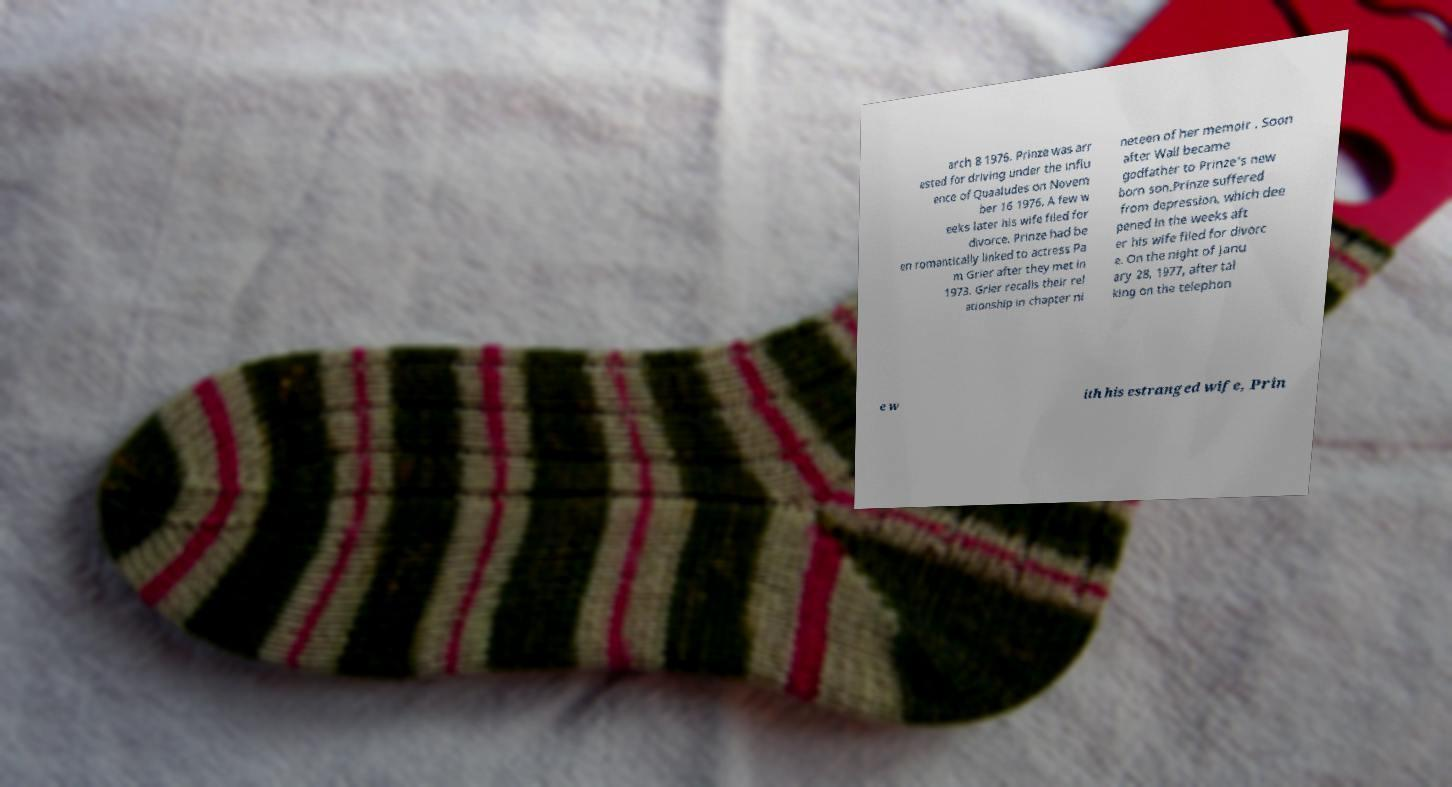Can you read and provide the text displayed in the image?This photo seems to have some interesting text. Can you extract and type it out for me? arch 8 1976. Prinze was arr ested for driving under the influ ence of Quaaludes on Novem ber 16 1976. A few w eeks later his wife filed for divorce. Prinze had be en romantically linked to actress Pa m Grier after they met in 1973. Grier recalls their rel ationship in chapter ni neteen of her memoir . Soon after Wall became godfather to Prinze's new born son.Prinze suffered from depression, which dee pened in the weeks aft er his wife filed for divorc e. On the night of Janu ary 28, 1977, after tal king on the telephon e w ith his estranged wife, Prin 